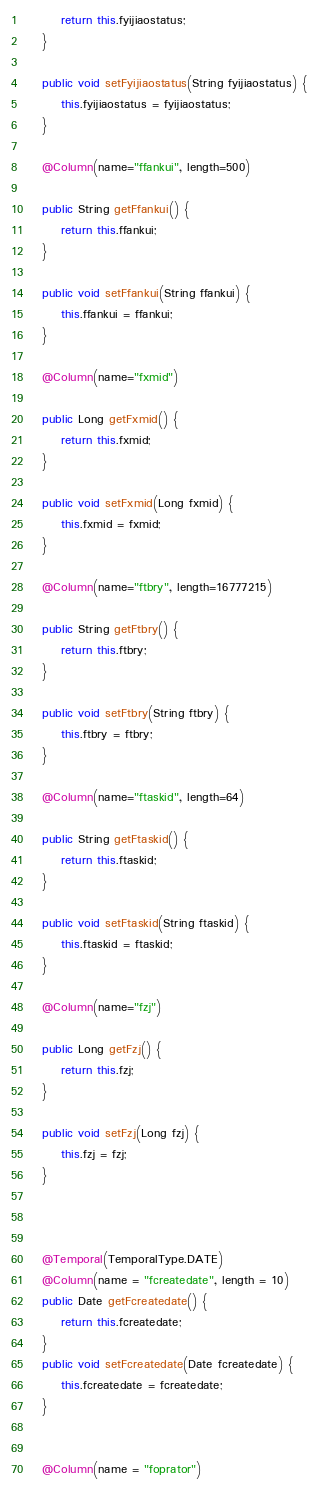<code> <loc_0><loc_0><loc_500><loc_500><_Java_>        return this.fyijiaostatus;
    }
    
    public void setFyijiaostatus(String fyijiaostatus) {
        this.fyijiaostatus = fyijiaostatus;
    }
    
    @Column(name="ffankui", length=500)

    public String getFfankui() {
        return this.ffankui;
    }
    
    public void setFfankui(String ffankui) {
        this.ffankui = ffankui;
    }
    
    @Column(name="fxmid")

    public Long getFxmid() {
        return this.fxmid;
    }
    
    public void setFxmid(Long fxmid) {
        this.fxmid = fxmid;
    }
    
    @Column(name="ftbry", length=16777215)

    public String getFtbry() {
        return this.ftbry;
    }
    
    public void setFtbry(String ftbry) {
        this.ftbry = ftbry;
    }
    
    @Column(name="ftaskid", length=64)

    public String getFtaskid() {
        return this.ftaskid;
    }
    
    public void setFtaskid(String ftaskid) {
        this.ftaskid = ftaskid;
    }
    
    @Column(name="fzj")

    public Long getFzj() {
        return this.fzj;
    }
    
    public void setFzj(Long fzj) {
        this.fzj = fzj;
    }



    @Temporal(TemporalType.DATE)
    @Column(name = "fcreatedate", length = 10)
    public Date getFcreatedate() {
        return this.fcreatedate;
    }
    public void setFcreatedate(Date fcreatedate) {
        this.fcreatedate = fcreatedate;
    }


    @Column(name = "foprator")</code> 